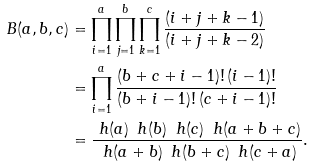<formula> <loc_0><loc_0><loc_500><loc_500>B ( a , b , c ) & = \prod _ { i = 1 } ^ { a } \prod _ { j = 1 } ^ { b } \prod _ { k = 1 } ^ { c } \frac { ( i + j + k - 1 ) } { ( i + j + k - 2 ) } \\ & = \prod _ { i = 1 } ^ { a } \frac { ( b + c + i - 1 ) ! \, ( i - 1 ) ! } { ( b + i - 1 ) ! \, ( c + i - 1 ) ! } \\ & = \frac { \ h ( a ) \, \ h ( b ) \, \ h ( c ) \, \ h ( a + b + c ) } { \ h ( a + b ) \, \ h ( b + c ) \, \ h ( c + a ) } .</formula> 